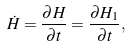Convert formula to latex. <formula><loc_0><loc_0><loc_500><loc_500>\dot { H } = \frac { \partial H } { \partial t } = \frac { \partial H _ { 1 } } { \partial t } ,</formula> 